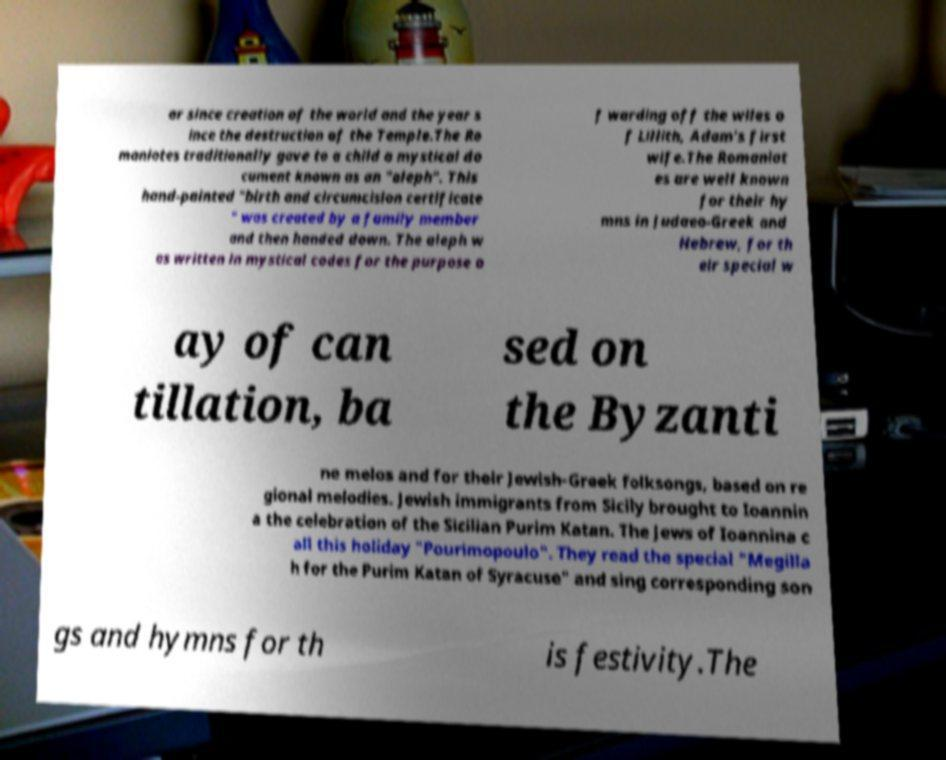For documentation purposes, I need the text within this image transcribed. Could you provide that? ar since creation of the world and the year s ince the destruction of the Temple.The Ro maniotes traditionally gave to a child a mystical do cument known as an "aleph". This hand-painted "birth and circumcision certificate " was created by a family member and then handed down. The aleph w as written in mystical codes for the purpose o f warding off the wiles o f Lillith, Adam's first wife.The Romaniot es are well known for their hy mns in Judaeo-Greek and Hebrew, for th eir special w ay of can tillation, ba sed on the Byzanti ne melos and for their Jewish-Greek folksongs, based on re gional melodies. Jewish immigrants from Sicily brought to Ioannin a the celebration of the Sicilian Purim Katan. The Jews of Ioannina c all this holiday "Pourimopoulo". They read the special "Megilla h for the Purim Katan of Syracuse" and sing corresponding son gs and hymns for th is festivity.The 